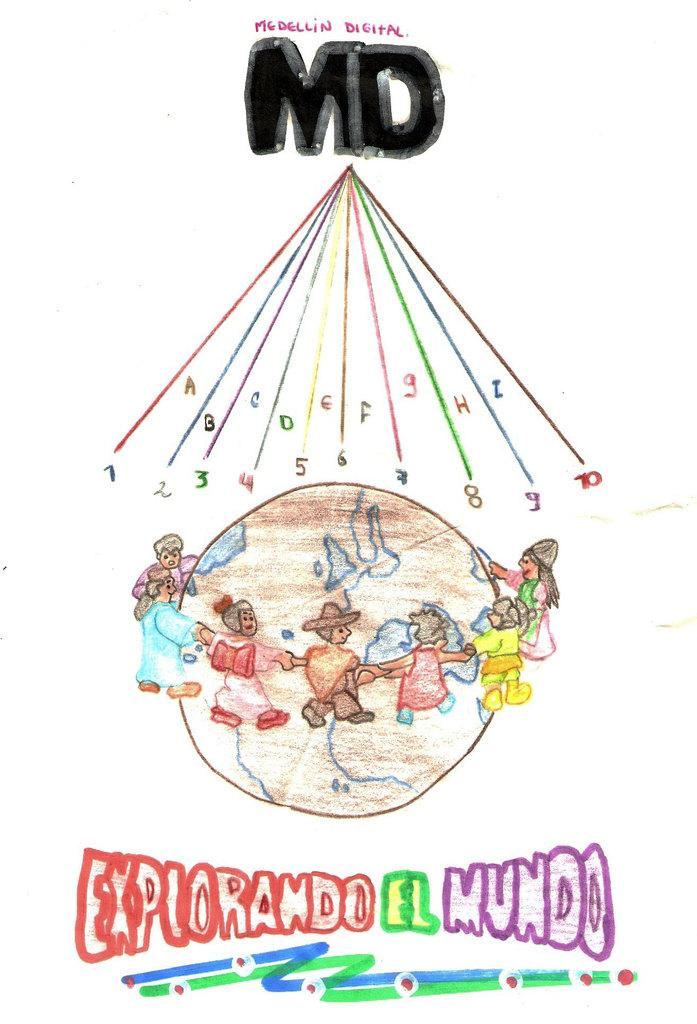<image>
Describe the image concisely. A poster shows people holding hands around a globe and reads "explorando el mundo". 